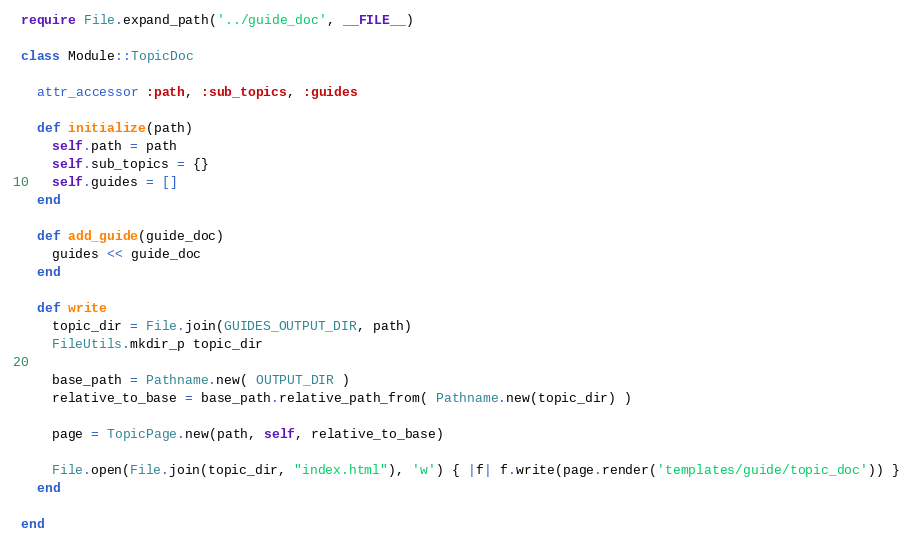Convert code to text. <code><loc_0><loc_0><loc_500><loc_500><_Ruby_>require File.expand_path('../guide_doc', __FILE__)

class Module::TopicDoc
  
  attr_accessor :path, :sub_topics, :guides
  
  def initialize(path)
    self.path = path
    self.sub_topics = {}
    self.guides = []
  end
  
  def add_guide(guide_doc)
    guides << guide_doc
  end
  
  def write
    topic_dir = File.join(GUIDES_OUTPUT_DIR, path)
    FileUtils.mkdir_p topic_dir

    base_path = Pathname.new( OUTPUT_DIR )
    relative_to_base = base_path.relative_path_from( Pathname.new(topic_dir) )

    page = TopicPage.new(path, self, relative_to_base)

    File.open(File.join(topic_dir, "index.html"), 'w') { |f| f.write(page.render('templates/guide/topic_doc')) }
  end
  
end</code> 